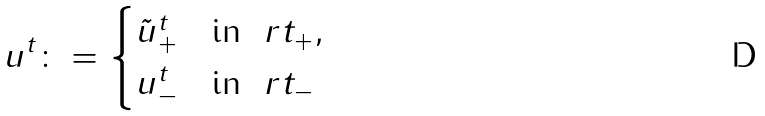<formula> <loc_0><loc_0><loc_500><loc_500>u ^ { t } \colon = \begin{cases} \tilde { u } _ { + } ^ { t } & \text {in } \ r t _ { + } , \\ u _ { - } ^ { t } & \text {in } \ r t _ { - } \end{cases}</formula> 